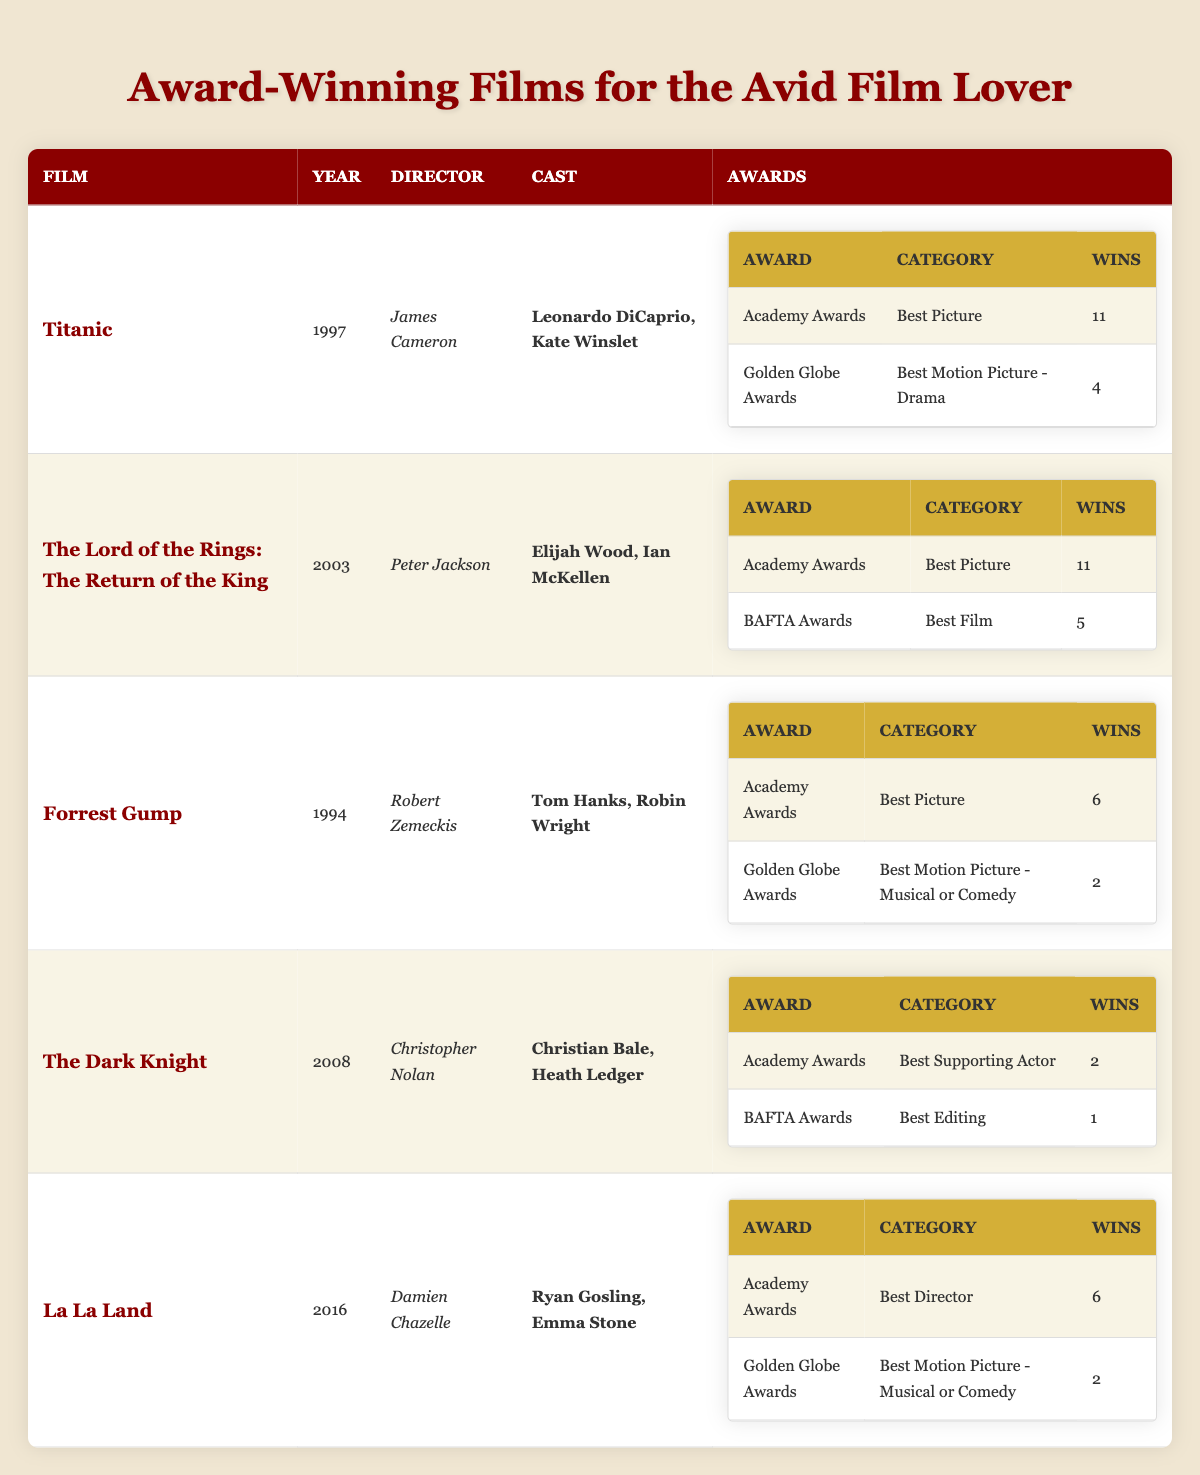What film won the most Academy Awards? According to the table, both "Titanic" and "The Lord of the Rings: The Return of the King" won 11 Academy Awards each, which is the highest number.
Answer: Titanic and The Lord of the Rings: The Return of the King Who directed Forrest Gump? The table lists the director of "Forrest Gump" as Robert Zemeckis in the respective row under the film's details.
Answer: Robert Zemeckis How many total wins did La La Land achieve across all awards? "La La Land" won 6 Academy Awards and 2 Golden Globe Awards, totaling 8 wins (6 + 2 = 8).
Answer: 8 Did The Dark Knight win more than 5 awards in total? "The Dark Knight" won a total of 3 awards (2 Academy Awards and 1 BAFTA Award), which is less than 5.
Answer: No Which actor starred in both Titanic and The Dark Knight? Referring to the cast information, Leonardo DiCaprio starred in "Titanic," while the cast of "The Dark Knight" includes Christian Bale and Heath Ledger, indicating that there is no overlapping actor between these two films.
Answer: No What is the average number of awards won by the films in the table? The total number of awards won by all the films is 6 (Titanic) + 2 (Forrest Gump) + 11 (The Lord of the Rings: The Return of the King) + 3 (The Dark Knight) + 8 (La La Land) = 30 awards. There are 5 films, so the average number of awards is 30/5 = 6.
Answer: 6 Which film has the most wins in the Golden Globe Awards category? The table shows that "Titanic" has 4 wins in the Golden Globe Awards for Best Motion Picture - Drama, while "La La Land" and "Forrest Gump" both have 2 wins. Thus, Titanic has the most wins in this category.
Answer: Titanic How many unique main actors are in the table that starred in these films? The unique actors listed in the films are Leonardo DiCaprio, Kate Winslet, Elijah Wood, Ian McKellen, Tom Hanks, Robin Wright, Christian Bale, Heath Ledger, Ryan Gosling, and Emma Stone, totaling 10 unique actors.
Answer: 10 